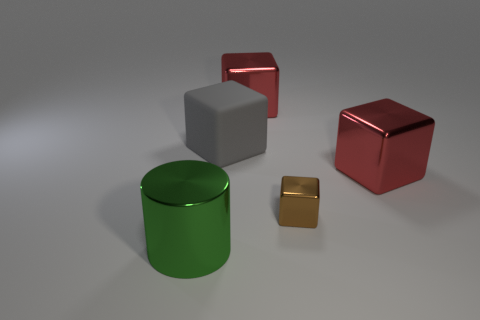Can you interpret the composition of the image? Certainly, the composition is minimalist and deliberate, with geometric shapes like cylinders and cubes evenly spaced, creating a sense of balance. The cool gray background contrasts with the vibrant color of the shapes, highlighting their form and placement. Do the objects have any reflectivity, and what does it indicate about the scene? Yes, the objects exhibit reflectivity, which implies that the surfaces are very smooth and possibly metallic. This reflectivity contributes to the perception of a clean, controlled environment, perhaps a studio setup meant for showcasing these items. 